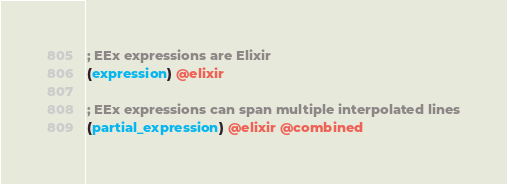Convert code to text. <code><loc_0><loc_0><loc_500><loc_500><_Scheme_>; EEx expressions are Elixir
(expression) @elixir

; EEx expressions can span multiple interpolated lines
(partial_expression) @elixir @combined
</code> 